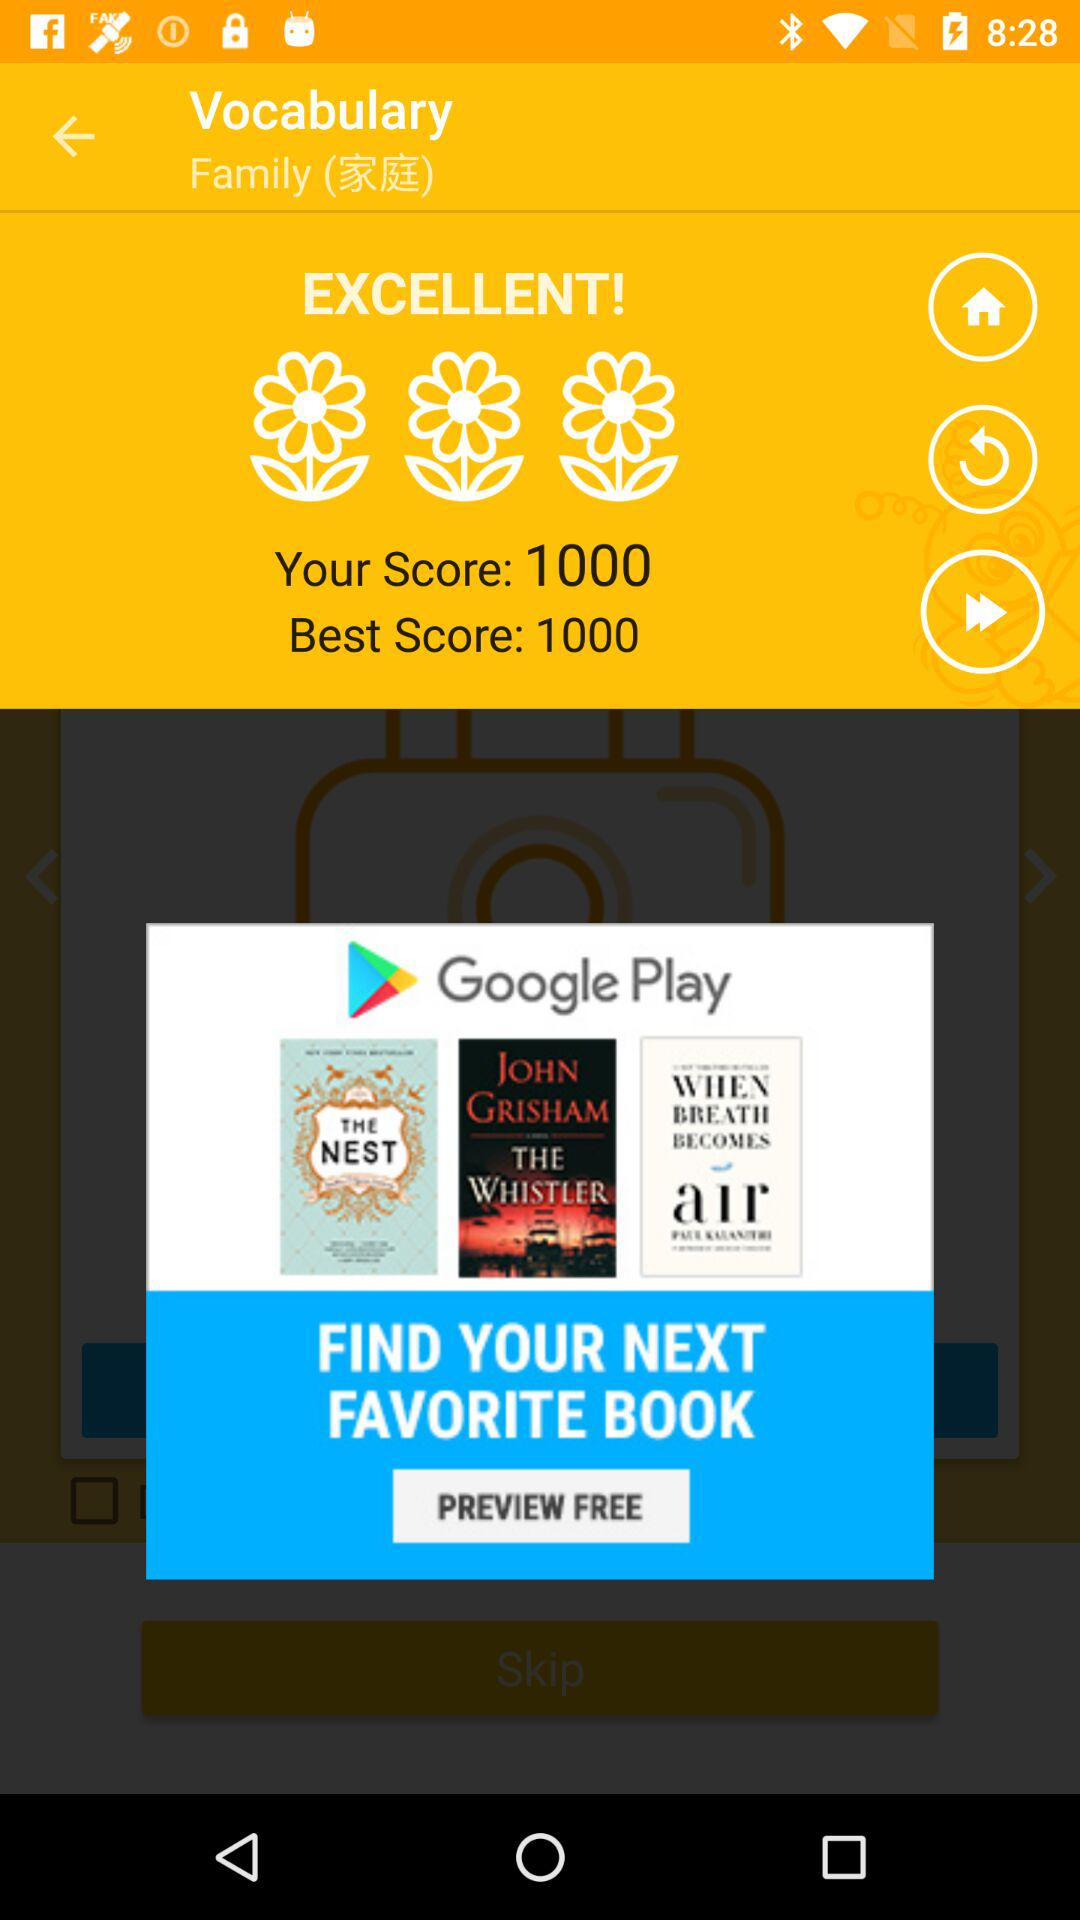What is the user's score? The user's score is 1000. 